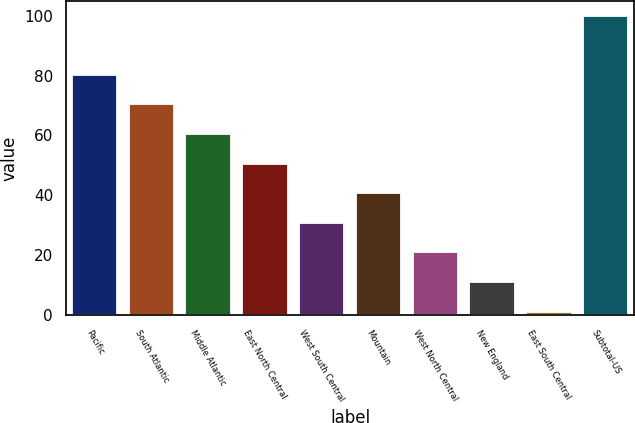Convert chart to OTSL. <chart><loc_0><loc_0><loc_500><loc_500><bar_chart><fcel>Pacific<fcel>South Atlantic<fcel>Middle Atlantic<fcel>East North Central<fcel>West South Central<fcel>Mountain<fcel>West North Central<fcel>New England<fcel>East South Central<fcel>Subtotal-US<nl><fcel>80.24<fcel>70.36<fcel>60.48<fcel>50.6<fcel>30.84<fcel>40.72<fcel>20.96<fcel>11.08<fcel>1.2<fcel>100<nl></chart> 